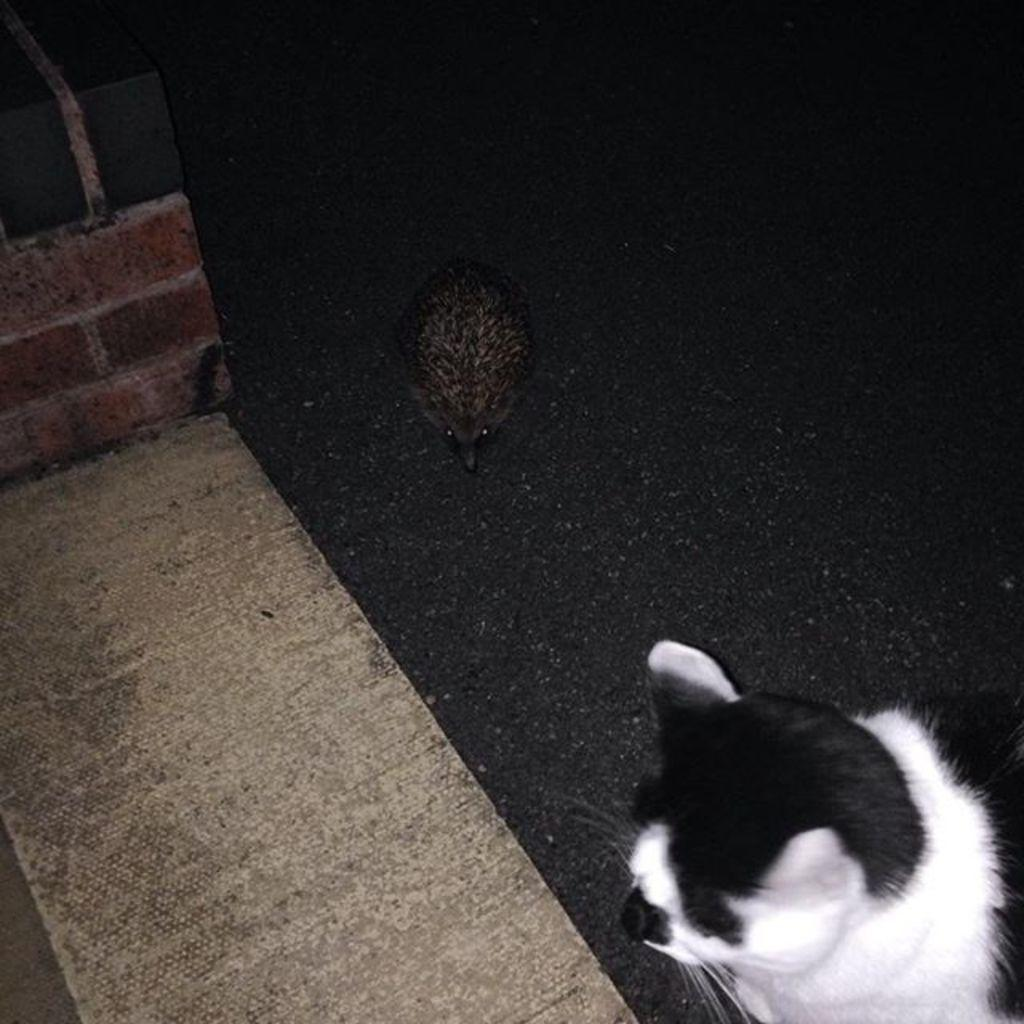What time of day was the image taken? The image was taken during night time. What type of animal can be seen in the image? There is a bird and a cat in the image. Where is the cat located in the image? The cat is on a path in the image. What is the material of the pillar on the left side of the image? The pillar has bricks on the left side of the image. What can be seen under the bird and cat in the image? The surface is visible in the image. What type of holiday is being celebrated in the image? There is no indication of a holiday being celebrated in the image. How many spiders are visible on the cat in the image? There are no spiders visible on the cat in the image. 